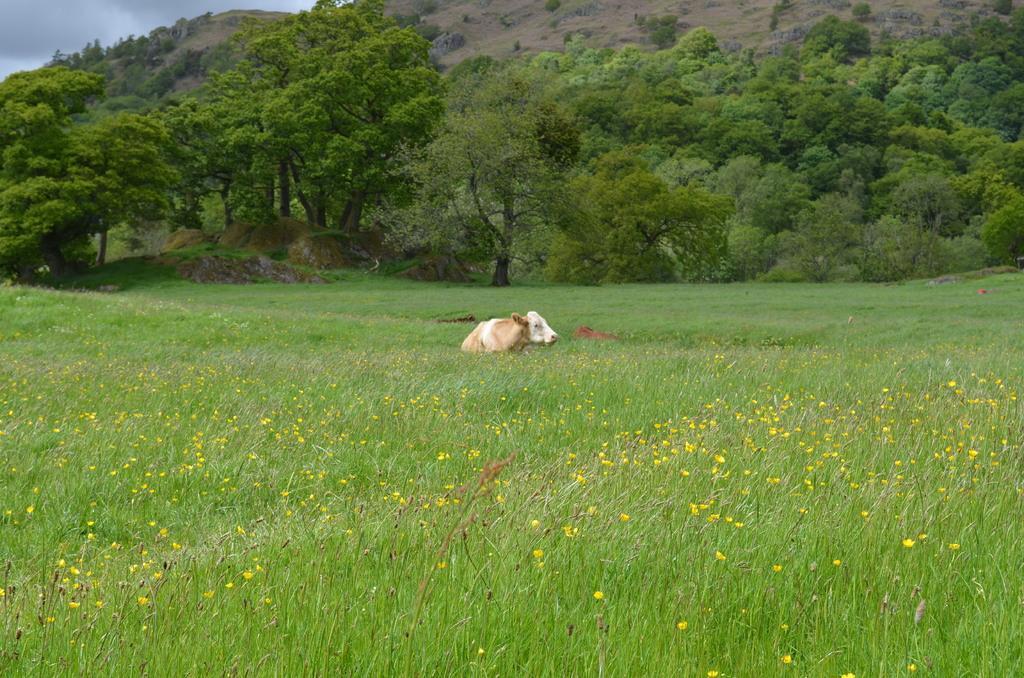In one or two sentences, can you explain what this image depicts? In the image there is a garden and there is a calf in between the grass, in the background there are trees and mountain. 